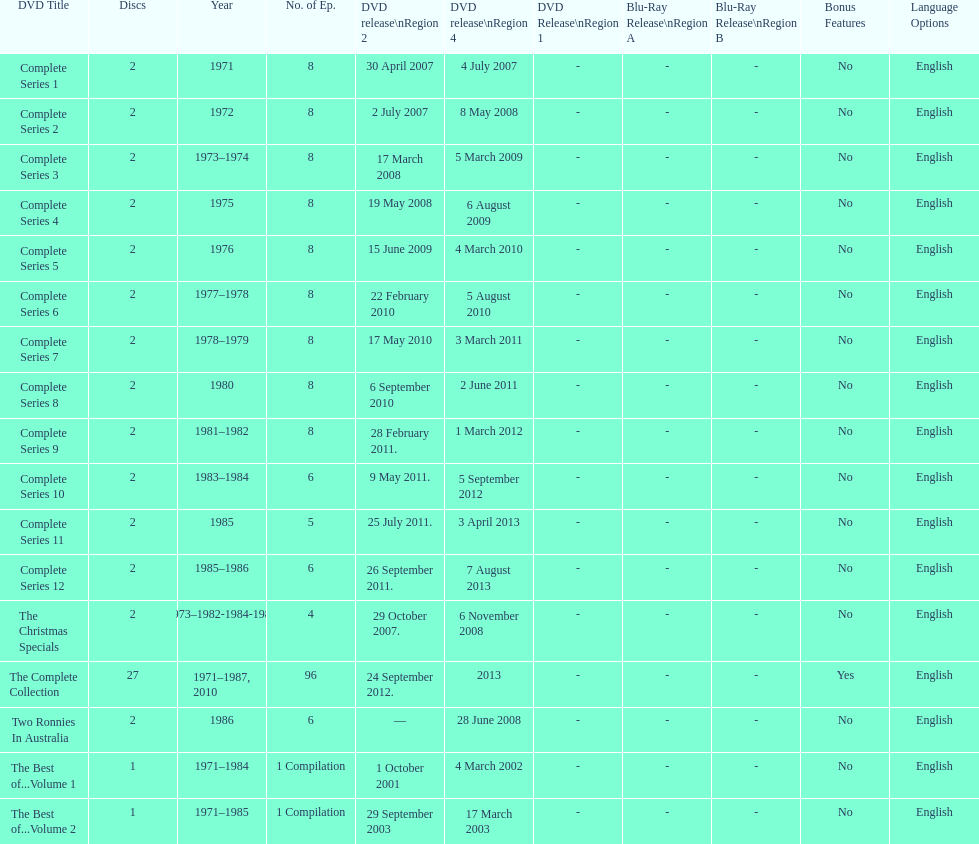What is the total of all dics listed in the table? 57. 